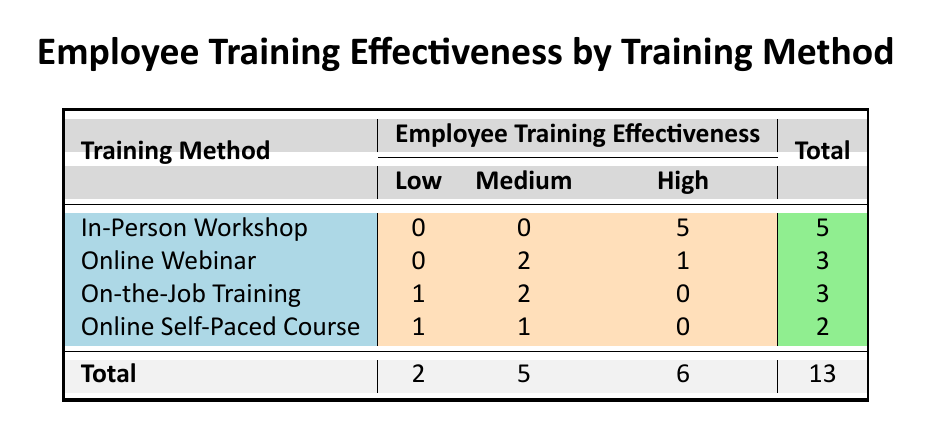What is the total number of training methods evaluated in the table? The table lists four distinct training methods: In-Person Workshop, Online Webinar, On-the-Job Training, and Online Self-Paced Course.
Answer: 4 How many franchise locations reported high employee training effectiveness? The table shows 5 entries under the 'High' category across different training methods, indicating that five franchise locations reported high effectiveness.
Answer: 5 Is there any training method that resulted in no reports of low effectiveness? By examining the table, we can see that 'In-Person Workshop', 'Online Webinar', and 'Online Self-Paced Course' have no entries under ‘Low’ effectiveness. Therefore, there are training methods without low effectiveness reports.
Answer: Yes What is the ratio of low effectiveness reports to high effectiveness reports? There are 2 reports of low effectiveness and 6 reports of high effectiveness. Thus, the ratio can be calculated as 2:6, which simplifies to 1:3.
Answer: 1:3 Which training method has the highest employee training effectiveness according to the table? By looking at the row with the highest count in the 'High' column, we find that 'In-Person Workshop' has 5 reports, which is the highest among all methods listed in the table.
Answer: In-Person Workshop What is the total number of medium effectiveness reports across all training methods? The table indicates a total of 5 reports of medium effectiveness when we combine the counts from 'Online Webinar' (2), 'On-the-Job Training' (2), and 'Online Self-Paced Course' (1). Summing these values gives 2 + 2 + 1 = 5.
Answer: 5 Can you determine the training method that has the lowest overall effectiveness? Looking at the counts, the 'On-the-Job Training' method has 1 low, 2 medium, and 0 high effectiveness reports, indicating it has a lower effectiveness profile compared to others.
Answer: On-the-Job Training What training method has only medium effectiveness reports? The training method 'Online Webinar' shows only medium (2) and high (1) effectiveness without any low effectiveness reports. Thus, it cannot be said to have 'only' medium effectiveness.
Answer: None 